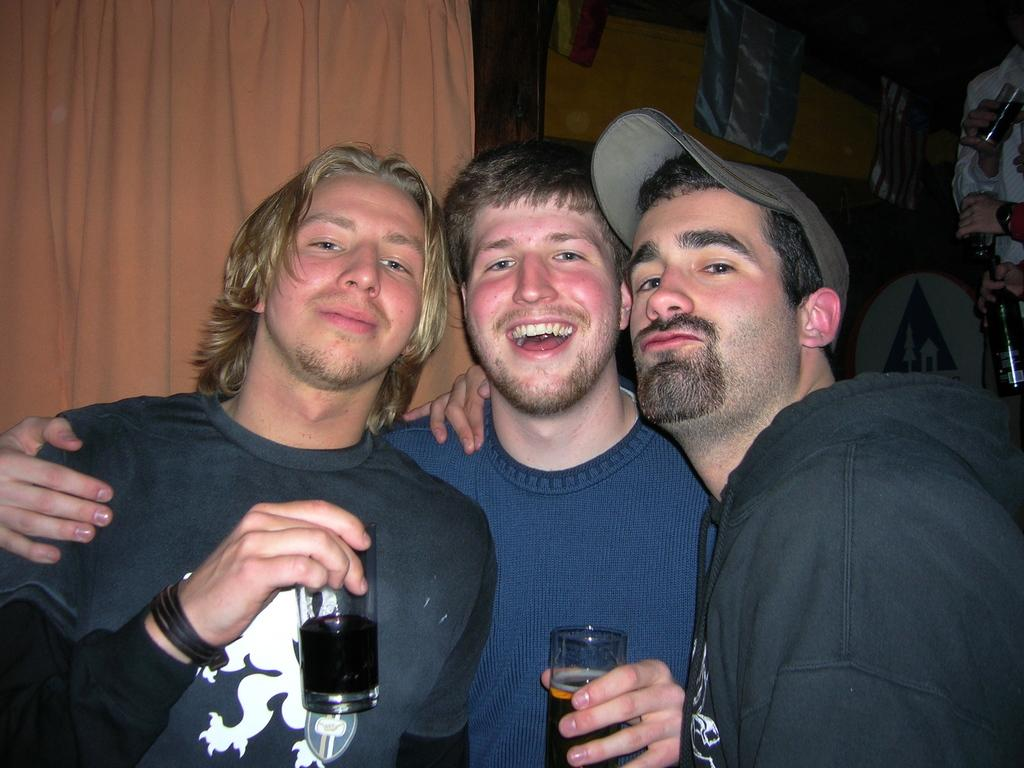What is the main subject of the image? There is a person standing in the image. What can be seen in the background of the image? There is a curtain, clothes, another person, and a wall in the background of the image. How many cars can be seen in the image? There are no cars present in the image. What type of fan is visible in the image? There is no fan present in the image. 